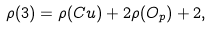Convert formula to latex. <formula><loc_0><loc_0><loc_500><loc_500>\rho ( 3 ) = \rho ( C u ) + 2 \rho ( O _ { p } ) + 2 ,</formula> 